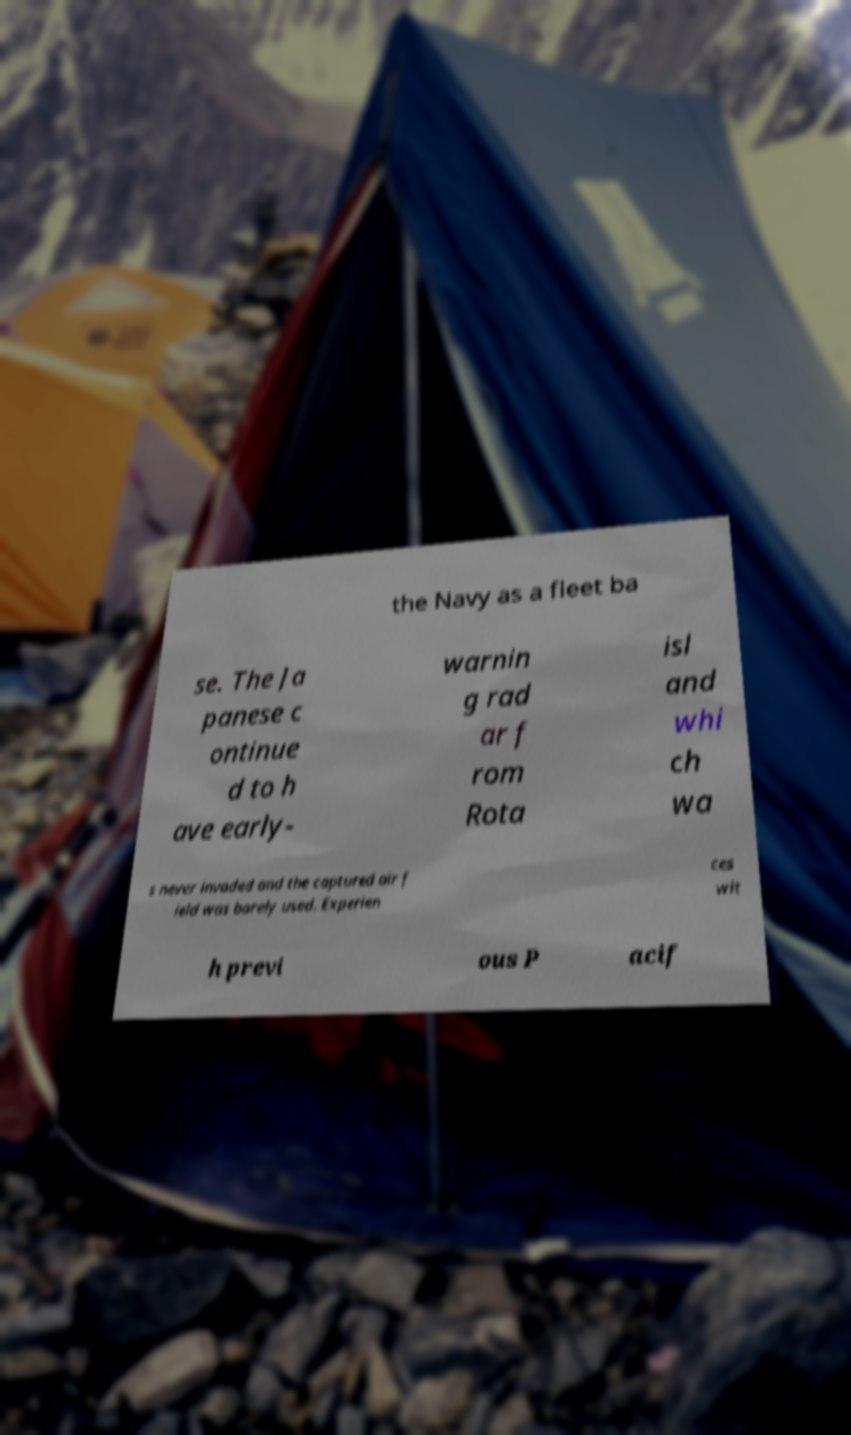What messages or text are displayed in this image? I need them in a readable, typed format. the Navy as a fleet ba se. The Ja panese c ontinue d to h ave early- warnin g rad ar f rom Rota isl and whi ch wa s never invaded and the captured air f ield was barely used. Experien ces wit h previ ous P acif 